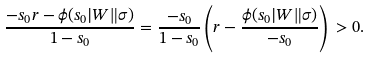<formula> <loc_0><loc_0><loc_500><loc_500>\frac { - s _ { 0 } r - { \phi } ( s _ { 0 } | W \| \sigma ) } { 1 - s _ { 0 } } = \frac { - s _ { 0 } } { 1 - s _ { 0 } } \left ( r - \frac { \phi ( s _ { 0 } | W \| \sigma ) } { - s _ { 0 } } \right ) \, > 0 .</formula> 